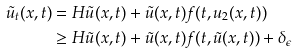<formula> <loc_0><loc_0><loc_500><loc_500>\tilde { u } _ { t } ( x , t ) & = H \tilde { u } ( x , t ) + \tilde { u } ( x , t ) f ( t , u _ { 2 } ( x , t ) ) \\ & \geq H \tilde { u } ( x , t ) + \tilde { u } ( x , t ) f ( t , \tilde { u } ( x , t ) ) + \delta _ { \epsilon }</formula> 